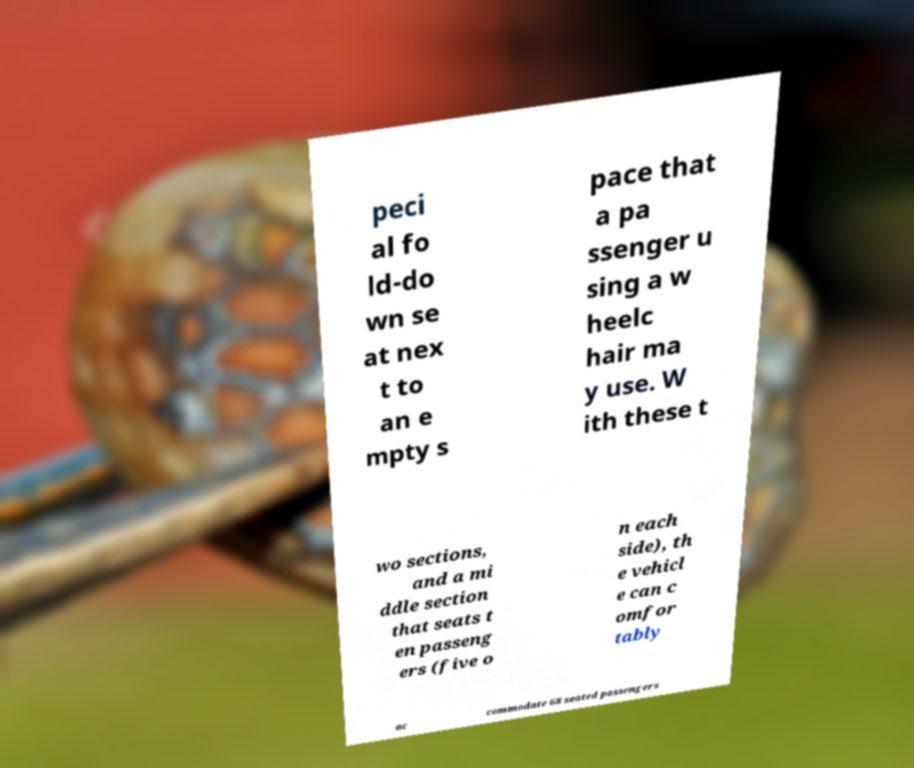Please identify and transcribe the text found in this image. peci al fo ld-do wn se at nex t to an e mpty s pace that a pa ssenger u sing a w heelc hair ma y use. W ith these t wo sections, and a mi ddle section that seats t en passeng ers (five o n each side), th e vehicl e can c omfor tably ac commodate 68 seated passengers 